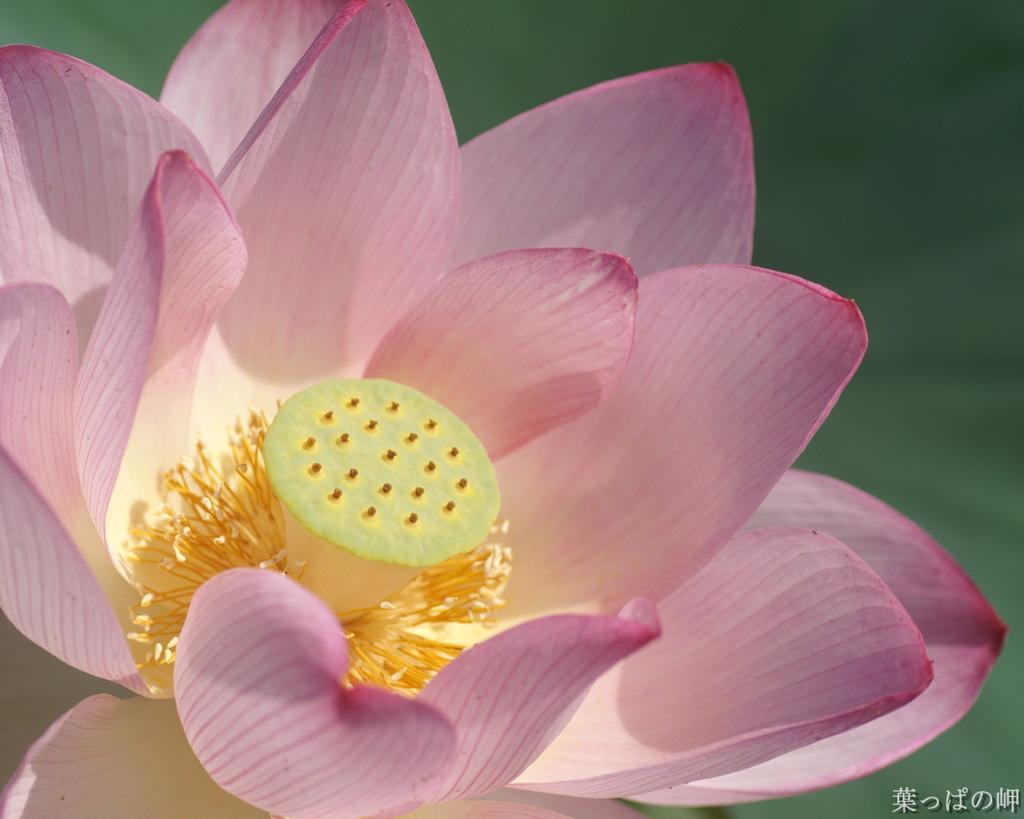In one or two sentences, can you explain what this image depicts? In this picture we can see a flower and there is a blur background. 